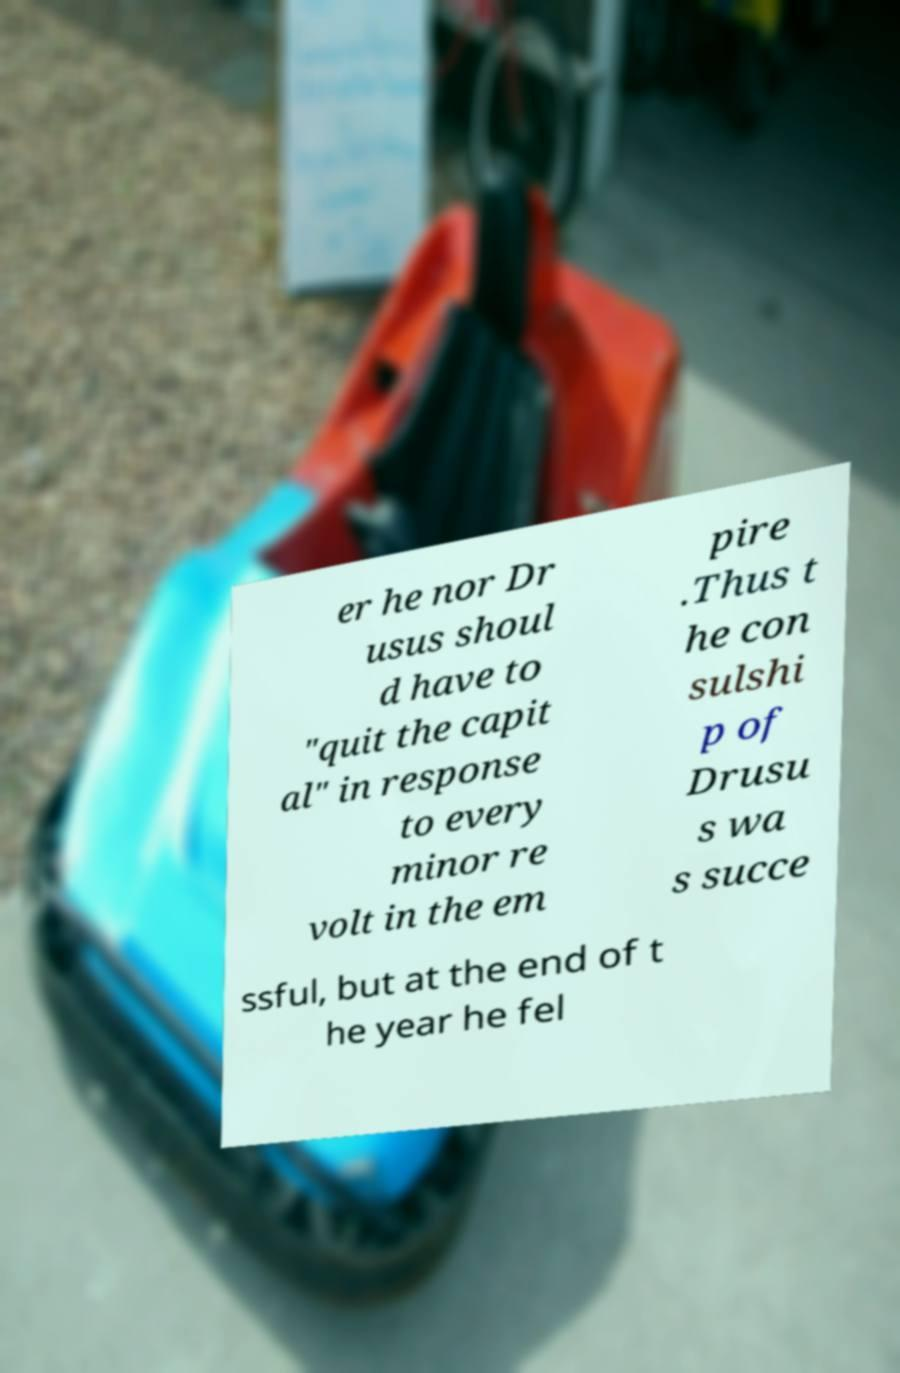Please read and relay the text visible in this image. What does it say? er he nor Dr usus shoul d have to "quit the capit al" in response to every minor re volt in the em pire .Thus t he con sulshi p of Drusu s wa s succe ssful, but at the end of t he year he fel 